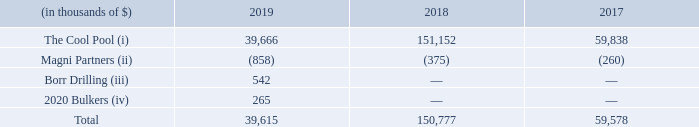D) transaction with other related parties:
net revenues/(expenses): the transactions with other related parties for the years ended december 31, 2019, 2018 and 2017 consisted of the following:
(i) the cool pool - on july 8, 2019 gaslog's vessel charter contracts had concluded and withdrew their participation from the cool pool. following gaslog's departure, we assumed sole responsibility for the management of the cool pool and consolidate the cool pool. from point of consolidation, the cool pool ceased to be a related party.
(ii) magni partners - tor olav trøim is the founder of, and partner in, magni partners (bermuda) limited, a privately held bermuda company, and is the ultimate beneficial owner of the company. receivables and payables from magni partners comprise primarily of the cost (without mark-up) or part cost of personnel employed by magni partners who have providedadvisory and management services to golar. these costs do not include any payment for any services provided by tor olav trøim himself.
iii) borr drilling - tor olav trøim is the founder, and director of borr drilling, a bermuda company listed on the oslo and nasdaq stock exchanges. receivables comprise primarily of management and administrative services provided by our bermuda corporate office.
iv) 2020 bulkers - 2020 bulkers is a related party by virtue of common directorships. receivables comprise primarily of management and administrative services provided by our bermuda corporate office.
in which years was the transaction with other related parties recorded for? 2019, 2018, 2017. What are the different parties involved with the transactions? The cool pool, magni partners, borr drilling, 2020 bulkers. Who is the founder of Borr Drilling? Tor olav trøim. In which year was the transaction with The Cool Pool the highest? 151,152 > 59,838 > 39,666
Answer: 2018. What was the change in total transaction with other related parties from 2018 to 2019?
Answer scale should be: thousand. 39,615 - 150,777 
Answer: -111162. What was the percentage change in total transaction with other related parties from 2017 to 2018?
Answer scale should be: percent. (150,777 - 59,578)/59,578 
Answer: 153.07. 